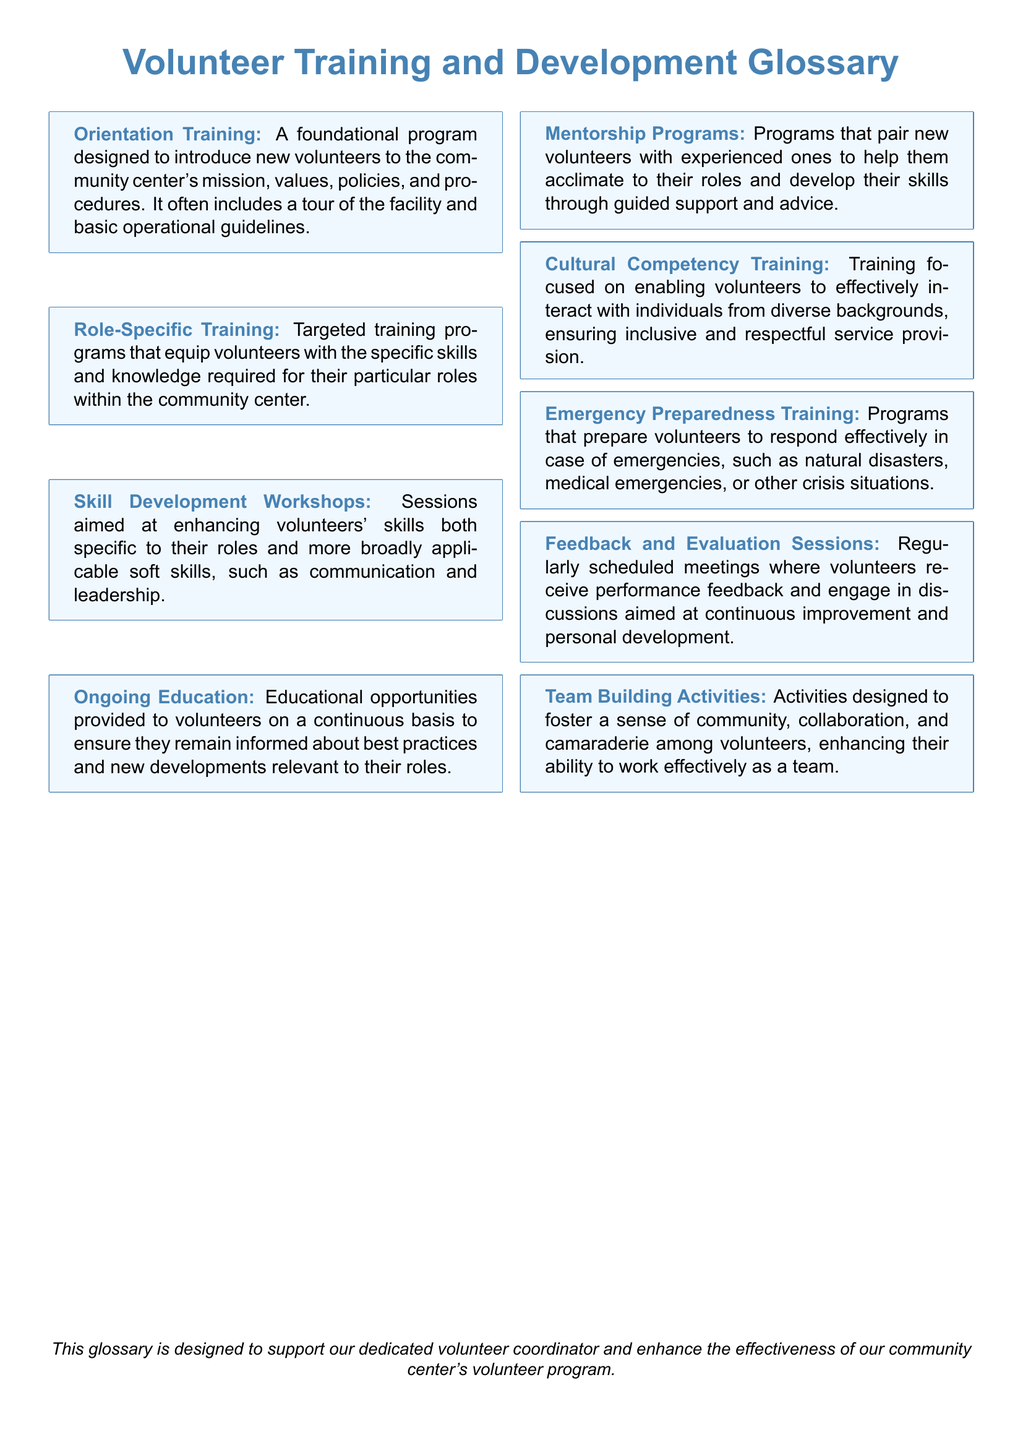What is the purpose of Orientation Training? Orientation Training introduces new volunteers to mission, values, policies, and procedures.
Answer: introduction to the community center's mission, values, policies, and procedures What is included in Role-Specific Training? Role-Specific Training equips volunteers with specific skills and knowledge for their roles.
Answer: specific skills and knowledge What are Skill Development Workshops aimed at? Skill Development Workshops enhance both role-specific and broad soft skills for volunteers.
Answer: enhancing volunteers' skills What does Ongoing Education provide? Ongoing Education provides continuous educational opportunities to remain informed about best practices.
Answer: educational opportunities What is the objective of Mentorship Programs? Mentorship Programs pair new volunteers with experienced ones for guidance and support.
Answer: guidance and support What kind of training is Cultural Competency Training? Cultural Competency Training focuses on effective interaction with diverse backgrounds.
Answer: effective interaction with diverse backgrounds What does Emergency Preparedness Training prepare volunteers for? Emergency Preparedness Training prepares volunteers to respond to emergencies like natural disasters or medical emergencies.
Answer: responding to emergencies What is the purpose of Feedback and Evaluation Sessions? Feedback and Evaluation Sessions provide performance feedback and discussions for continuous improvement.
Answer: performance feedback What do Team Building Activities aim to enhance? Team Building Activities aim to foster community, collaboration, and camaraderie among volunteers.
Answer: community, collaboration, and camaraderie 